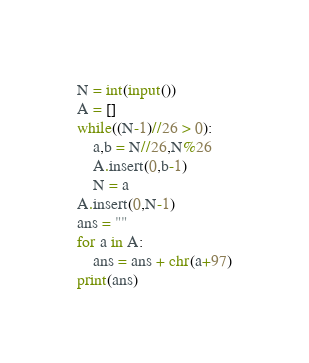Convert code to text. <code><loc_0><loc_0><loc_500><loc_500><_Python_>N = int(input())
A = []
while((N-1)//26 > 0):
    a,b = N//26,N%26
    A.insert(0,b-1)
    N = a
A.insert(0,N-1)
ans = ""
for a in A:
    ans = ans + chr(a+97)
print(ans)</code> 